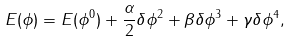Convert formula to latex. <formula><loc_0><loc_0><loc_500><loc_500>E ( \phi ) = E ( \phi ^ { 0 } ) + \frac { \alpha } { 2 } \delta \phi ^ { 2 } + \beta \delta \phi ^ { 3 } + \gamma \delta \phi ^ { 4 } ,</formula> 